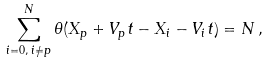Convert formula to latex. <formula><loc_0><loc_0><loc_500><loc_500>\sum _ { i = 0 , \, i \neq p } ^ { N } \theta ( X _ { p } + V _ { p } t - X _ { i } - V _ { i } t ) = N \, ,</formula> 